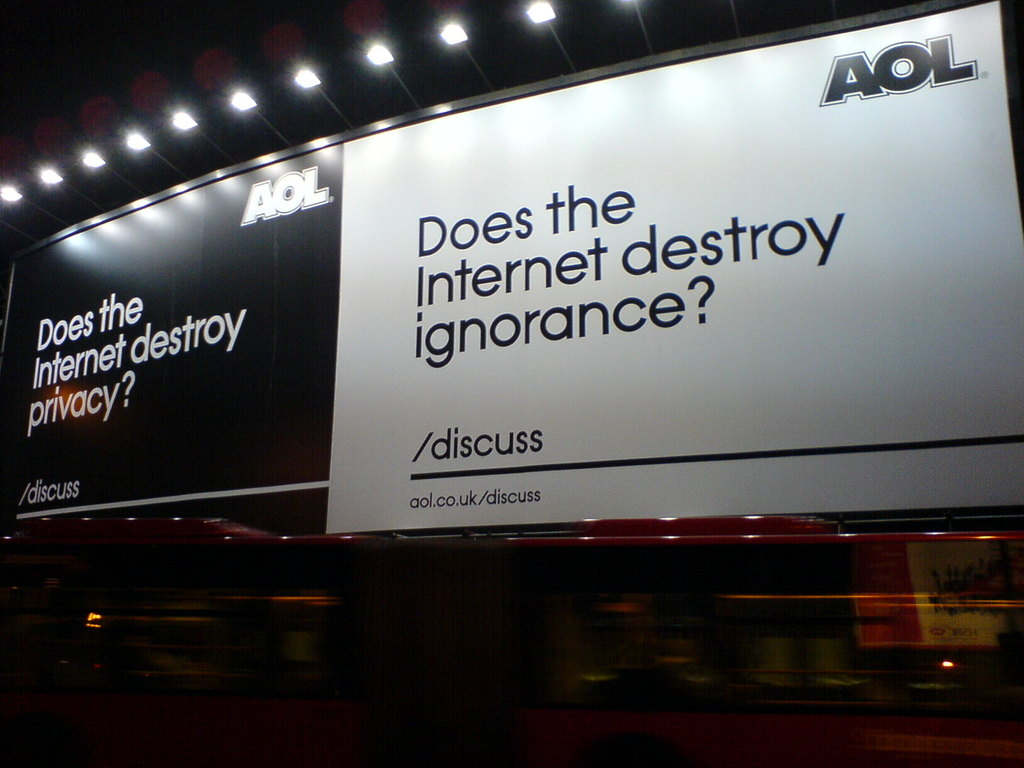Can you elaborate on the elements of the picture provided? The image depicts an intriguing AOL advertisement on the side of a bus, which displays two provocative questions: 'Does the Internet destroy privacy?' and 'Does the Internet destroy ignorance?', each followed by the command '/discuss'. The choice of a stark black background with white text not only ensures high visibility but also symbolically represents the contrasting perspectives these questions could elicit. By inviting viewers to discuss these questions at 'aol.co.uk/discuss', the advertisement not only promotes AOL's platform but also engages the public in vital conversations about the broader implications of internet usage on privacy and knowledge acquisition. 